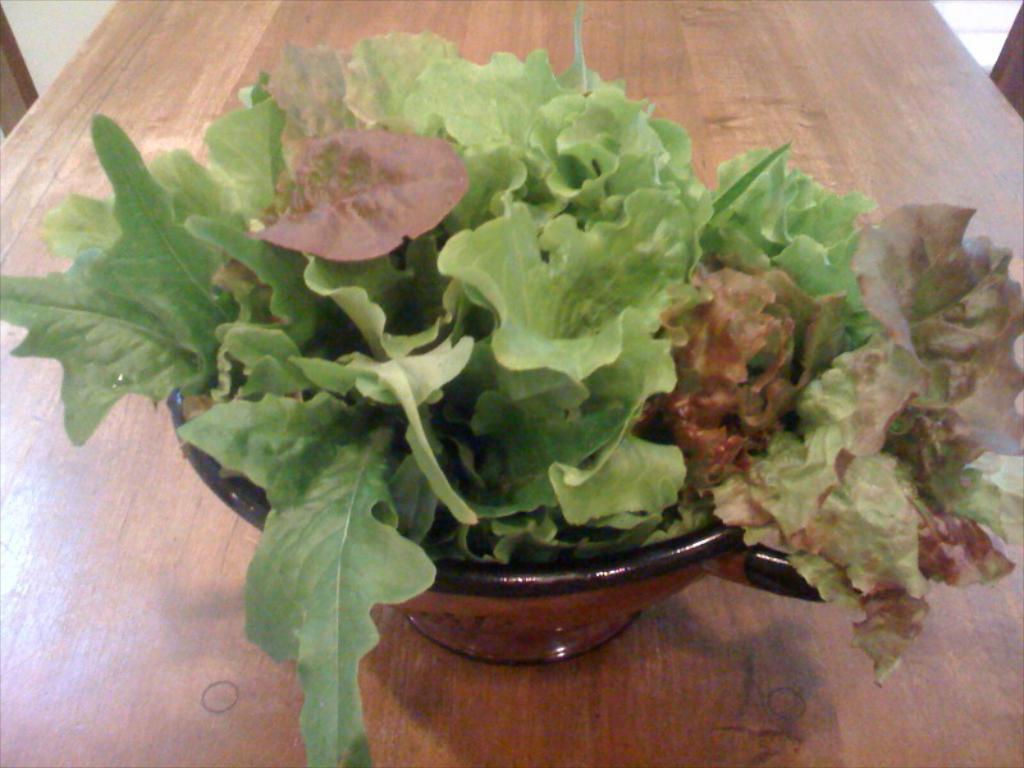In one or two sentences, can you explain what this image depicts? In this picture we can see a flower pot with green leaves kept on a brown wooden table. 